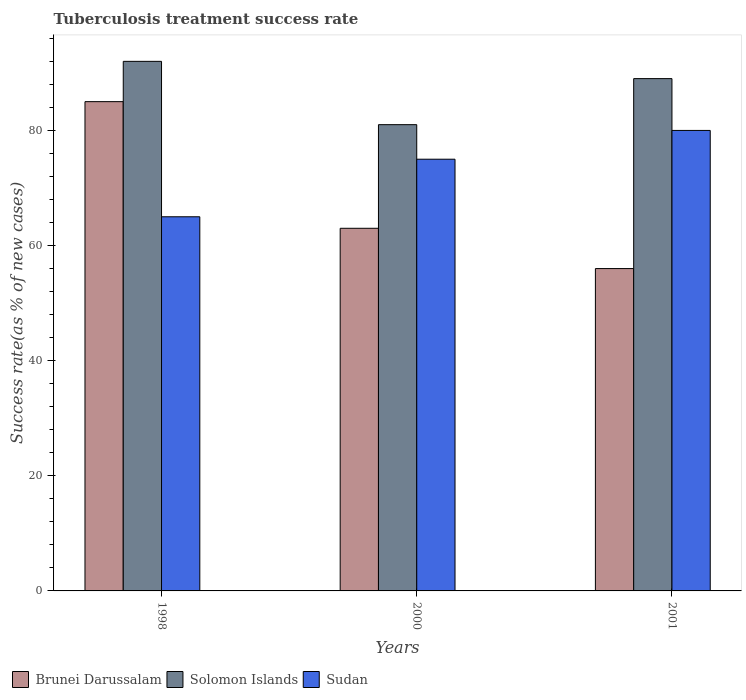How many bars are there on the 3rd tick from the right?
Make the answer very short. 3. What is the label of the 1st group of bars from the left?
Your answer should be very brief. 1998. What is the tuberculosis treatment success rate in Sudan in 2001?
Make the answer very short. 80. Across all years, what is the maximum tuberculosis treatment success rate in Brunei Darussalam?
Offer a terse response. 85. Across all years, what is the minimum tuberculosis treatment success rate in Sudan?
Your response must be concise. 65. In which year was the tuberculosis treatment success rate in Brunei Darussalam maximum?
Your answer should be very brief. 1998. In which year was the tuberculosis treatment success rate in Brunei Darussalam minimum?
Your answer should be compact. 2001. What is the total tuberculosis treatment success rate in Sudan in the graph?
Make the answer very short. 220. What is the difference between the tuberculosis treatment success rate in Sudan in 1998 and that in 2000?
Your response must be concise. -10. What is the difference between the tuberculosis treatment success rate in Brunei Darussalam in 2000 and the tuberculosis treatment success rate in Solomon Islands in 1998?
Provide a short and direct response. -29. What is the ratio of the tuberculosis treatment success rate in Sudan in 1998 to that in 2000?
Your answer should be compact. 0.87. Is the tuberculosis treatment success rate in Sudan in 1998 less than that in 2000?
Your response must be concise. Yes. Is the difference between the tuberculosis treatment success rate in Brunei Darussalam in 1998 and 2000 greater than the difference between the tuberculosis treatment success rate in Solomon Islands in 1998 and 2000?
Your answer should be very brief. Yes. What does the 2nd bar from the left in 1998 represents?
Keep it short and to the point. Solomon Islands. What does the 1st bar from the right in 1998 represents?
Make the answer very short. Sudan. How many bars are there?
Your response must be concise. 9. What is the difference between two consecutive major ticks on the Y-axis?
Provide a succinct answer. 20. Are the values on the major ticks of Y-axis written in scientific E-notation?
Offer a terse response. No. Does the graph contain any zero values?
Your answer should be very brief. No. How many legend labels are there?
Your response must be concise. 3. How are the legend labels stacked?
Make the answer very short. Horizontal. What is the title of the graph?
Provide a succinct answer. Tuberculosis treatment success rate. Does "Suriname" appear as one of the legend labels in the graph?
Keep it short and to the point. No. What is the label or title of the Y-axis?
Make the answer very short. Success rate(as % of new cases). What is the Success rate(as % of new cases) in Solomon Islands in 1998?
Provide a short and direct response. 92. What is the Success rate(as % of new cases) of Brunei Darussalam in 2001?
Offer a terse response. 56. What is the Success rate(as % of new cases) of Solomon Islands in 2001?
Your answer should be very brief. 89. Across all years, what is the maximum Success rate(as % of new cases) of Solomon Islands?
Provide a succinct answer. 92. Across all years, what is the minimum Success rate(as % of new cases) of Sudan?
Your response must be concise. 65. What is the total Success rate(as % of new cases) of Brunei Darussalam in the graph?
Your answer should be very brief. 204. What is the total Success rate(as % of new cases) of Solomon Islands in the graph?
Give a very brief answer. 262. What is the total Success rate(as % of new cases) in Sudan in the graph?
Make the answer very short. 220. What is the difference between the Success rate(as % of new cases) in Sudan in 1998 and that in 2000?
Your answer should be compact. -10. What is the difference between the Success rate(as % of new cases) of Solomon Islands in 1998 and that in 2001?
Make the answer very short. 3. What is the difference between the Success rate(as % of new cases) of Sudan in 1998 and that in 2001?
Give a very brief answer. -15. What is the difference between the Success rate(as % of new cases) in Brunei Darussalam in 1998 and the Success rate(as % of new cases) in Solomon Islands in 2000?
Offer a terse response. 4. What is the difference between the Success rate(as % of new cases) of Solomon Islands in 1998 and the Success rate(as % of new cases) of Sudan in 2000?
Ensure brevity in your answer.  17. What is the difference between the Success rate(as % of new cases) in Solomon Islands in 1998 and the Success rate(as % of new cases) in Sudan in 2001?
Your answer should be very brief. 12. What is the difference between the Success rate(as % of new cases) in Brunei Darussalam in 2000 and the Success rate(as % of new cases) in Solomon Islands in 2001?
Keep it short and to the point. -26. What is the difference between the Success rate(as % of new cases) in Brunei Darussalam in 2000 and the Success rate(as % of new cases) in Sudan in 2001?
Offer a very short reply. -17. What is the average Success rate(as % of new cases) of Solomon Islands per year?
Provide a succinct answer. 87.33. What is the average Success rate(as % of new cases) in Sudan per year?
Provide a short and direct response. 73.33. In the year 1998, what is the difference between the Success rate(as % of new cases) in Brunei Darussalam and Success rate(as % of new cases) in Solomon Islands?
Your answer should be very brief. -7. In the year 1998, what is the difference between the Success rate(as % of new cases) in Brunei Darussalam and Success rate(as % of new cases) in Sudan?
Your answer should be compact. 20. In the year 2000, what is the difference between the Success rate(as % of new cases) in Brunei Darussalam and Success rate(as % of new cases) in Solomon Islands?
Offer a very short reply. -18. In the year 2000, what is the difference between the Success rate(as % of new cases) of Brunei Darussalam and Success rate(as % of new cases) of Sudan?
Provide a short and direct response. -12. In the year 2001, what is the difference between the Success rate(as % of new cases) in Brunei Darussalam and Success rate(as % of new cases) in Solomon Islands?
Provide a short and direct response. -33. In the year 2001, what is the difference between the Success rate(as % of new cases) in Brunei Darussalam and Success rate(as % of new cases) in Sudan?
Provide a succinct answer. -24. In the year 2001, what is the difference between the Success rate(as % of new cases) of Solomon Islands and Success rate(as % of new cases) of Sudan?
Give a very brief answer. 9. What is the ratio of the Success rate(as % of new cases) of Brunei Darussalam in 1998 to that in 2000?
Provide a short and direct response. 1.35. What is the ratio of the Success rate(as % of new cases) in Solomon Islands in 1998 to that in 2000?
Offer a terse response. 1.14. What is the ratio of the Success rate(as % of new cases) in Sudan in 1998 to that in 2000?
Ensure brevity in your answer.  0.87. What is the ratio of the Success rate(as % of new cases) of Brunei Darussalam in 1998 to that in 2001?
Ensure brevity in your answer.  1.52. What is the ratio of the Success rate(as % of new cases) in Solomon Islands in 1998 to that in 2001?
Provide a succinct answer. 1.03. What is the ratio of the Success rate(as % of new cases) of Sudan in 1998 to that in 2001?
Your answer should be compact. 0.81. What is the ratio of the Success rate(as % of new cases) of Brunei Darussalam in 2000 to that in 2001?
Your answer should be very brief. 1.12. What is the ratio of the Success rate(as % of new cases) in Solomon Islands in 2000 to that in 2001?
Make the answer very short. 0.91. What is the ratio of the Success rate(as % of new cases) of Sudan in 2000 to that in 2001?
Keep it short and to the point. 0.94. What is the difference between the highest and the lowest Success rate(as % of new cases) of Brunei Darussalam?
Give a very brief answer. 29. What is the difference between the highest and the lowest Success rate(as % of new cases) of Solomon Islands?
Offer a very short reply. 11. 